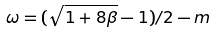<formula> <loc_0><loc_0><loc_500><loc_500>\omega = ( \sqrt { 1 + 8 \beta } - 1 ) / 2 - m</formula> 